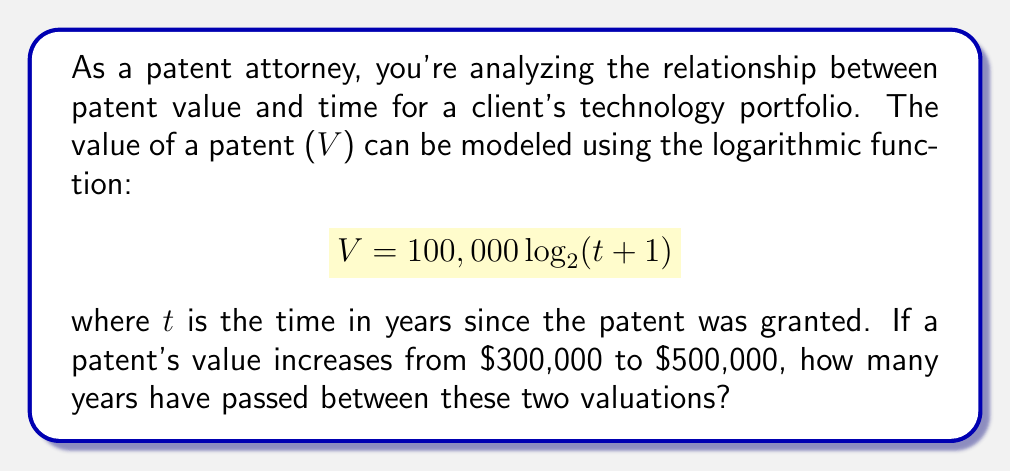Provide a solution to this math problem. Let's approach this step-by-step:

1) We're given the function $V = 100,000 \log_{2}(t+1)$

2) We need to find the difference in time ($\Delta t$) between when $V = 300,000$ and when $V = 500,000$

3) Let's start with $V = 300,000$:

   $300,000 = 100,000 \log_{2}(t_1+1)$
   $3 = \log_{2}(t_1+1)$
   $2^3 = t_1+1$
   $8 = t_1+1$
   $t_1 = 7$ years

4) Now for $V = 500,000$:

   $500,000 = 100,000 \log_{2}(t_2+1)$
   $5 = \log_{2}(t_2+1)$
   $2^5 = t_2+1$
   $32 = t_2+1$
   $t_2 = 31$ years

5) The time difference is:

   $\Delta t = t_2 - t_1 = 31 - 7 = 24$ years

Therefore, 24 years have passed between these two valuations.
Answer: 24 years 